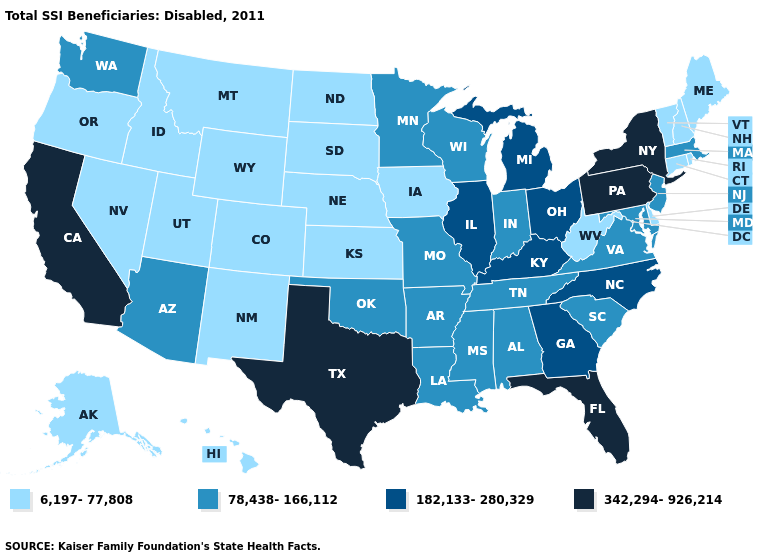Does Minnesota have the highest value in the MidWest?
Answer briefly. No. Among the states that border Tennessee , does Mississippi have the highest value?
Concise answer only. No. What is the lowest value in the South?
Quick response, please. 6,197-77,808. Among the states that border Maine , which have the highest value?
Write a very short answer. New Hampshire. Does the first symbol in the legend represent the smallest category?
Answer briefly. Yes. Does Nebraska have the highest value in the USA?
Keep it brief. No. Does Montana have a lower value than Louisiana?
Write a very short answer. Yes. Among the states that border Kentucky , which have the highest value?
Be succinct. Illinois, Ohio. Name the states that have a value in the range 78,438-166,112?
Keep it brief. Alabama, Arizona, Arkansas, Indiana, Louisiana, Maryland, Massachusetts, Minnesota, Mississippi, Missouri, New Jersey, Oklahoma, South Carolina, Tennessee, Virginia, Washington, Wisconsin. What is the value of Hawaii?
Keep it brief. 6,197-77,808. Does Vermont have the highest value in the Northeast?
Answer briefly. No. What is the value of Nebraska?
Short answer required. 6,197-77,808. What is the value of North Dakota?
Concise answer only. 6,197-77,808. What is the value of California?
Answer briefly. 342,294-926,214. Which states have the highest value in the USA?
Be succinct. California, Florida, New York, Pennsylvania, Texas. 